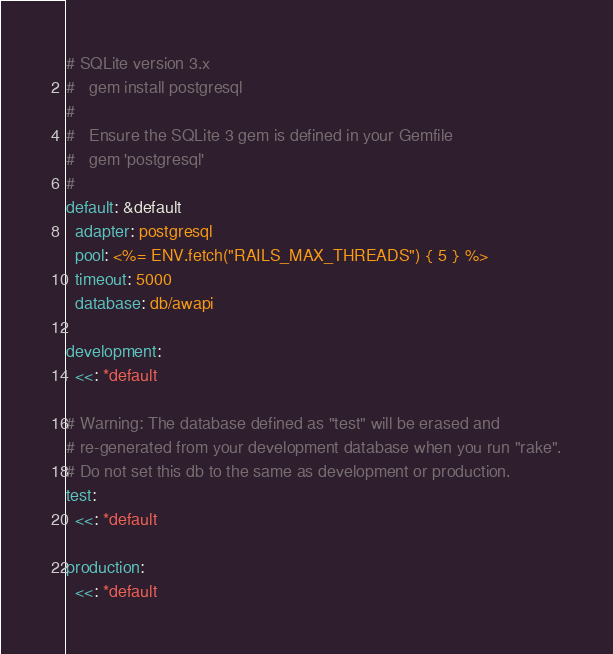Convert code to text. <code><loc_0><loc_0><loc_500><loc_500><_YAML_># SQLite version 3.x
#   gem install postgresql
#
#   Ensure the SQLite 3 gem is defined in your Gemfile
#   gem 'postgresql'
#
default: &default
  adapter: postgresql
  pool: <%= ENV.fetch("RAILS_MAX_THREADS") { 5 } %>
  timeout: 5000
  database: db/awapi

development:
  <<: *default

# Warning: The database defined as "test" will be erased and
# re-generated from your development database when you run "rake".
# Do not set this db to the same as development or production.
test:
  <<: *default

production:
  <<: *default
</code> 